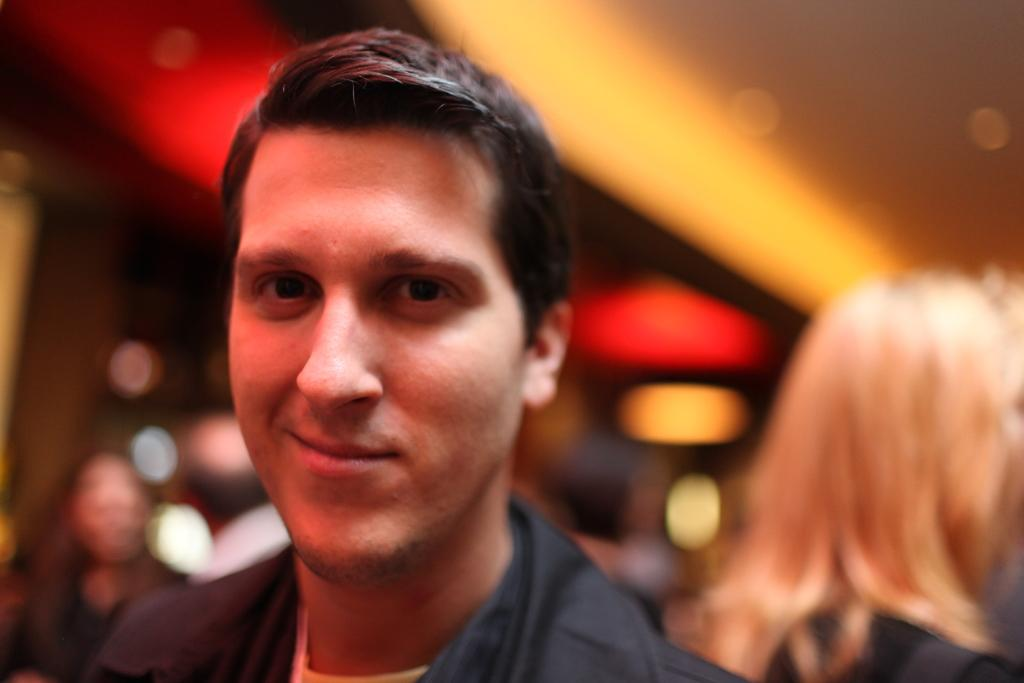Who is in the image? There is a person in the image. What is the person wearing? The person is wearing a black dress. What expression does the person have? The person is smiling. Can you describe the background of the image? The background of the image is blurry. Are there any other people visible in the image? Yes, there are a few other people visible in the background. What type of produce can be seen on the person's wrist in the image? There is no produce visible on the person's wrist in the image. 